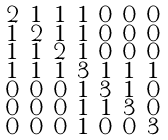<formula> <loc_0><loc_0><loc_500><loc_500>\begin{smallmatrix} 2 & 1 & 1 & 1 & 0 & 0 & 0 \\ 1 & 2 & 1 & 1 & 0 & 0 & 0 \\ 1 & 1 & 2 & 1 & 0 & 0 & 0 \\ 1 & 1 & 1 & 3 & 1 & 1 & 1 \\ 0 & 0 & 0 & 1 & 3 & 1 & 0 \\ 0 & 0 & 0 & 1 & 1 & 3 & 0 \\ 0 & 0 & 0 & 1 & 0 & 0 & 3 \end{smallmatrix}</formula> 